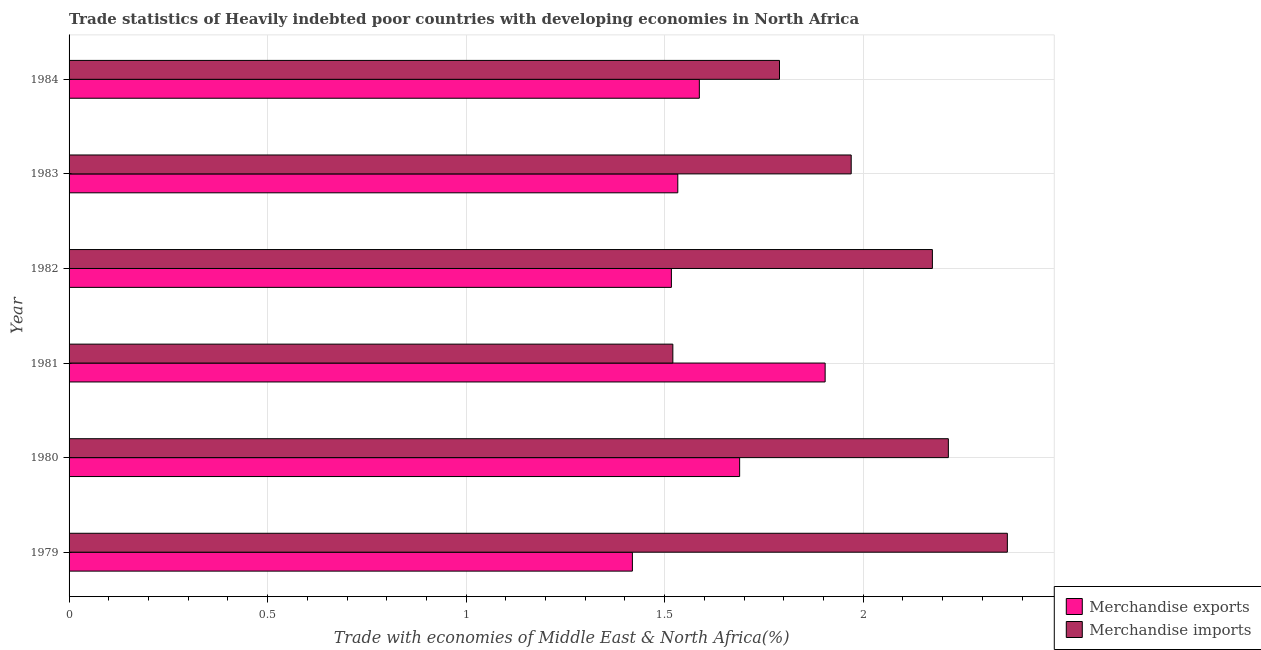Are the number of bars per tick equal to the number of legend labels?
Keep it short and to the point. Yes. How many bars are there on the 6th tick from the top?
Keep it short and to the point. 2. What is the label of the 4th group of bars from the top?
Offer a terse response. 1981. What is the merchandise imports in 1984?
Offer a terse response. 1.79. Across all years, what is the maximum merchandise exports?
Your answer should be very brief. 1.9. Across all years, what is the minimum merchandise exports?
Your answer should be very brief. 1.42. In which year was the merchandise imports maximum?
Ensure brevity in your answer.  1979. In which year was the merchandise exports minimum?
Keep it short and to the point. 1979. What is the total merchandise imports in the graph?
Your answer should be compact. 12.03. What is the difference between the merchandise exports in 1983 and that in 1984?
Make the answer very short. -0.05. What is the difference between the merchandise exports in 1979 and the merchandise imports in 1984?
Your response must be concise. -0.37. What is the average merchandise exports per year?
Give a very brief answer. 1.61. In the year 1979, what is the difference between the merchandise exports and merchandise imports?
Your response must be concise. -0.94. In how many years, is the merchandise exports greater than 1 %?
Keep it short and to the point. 6. What is the ratio of the merchandise exports in 1979 to that in 1983?
Your answer should be compact. 0.93. Is the merchandise exports in 1981 less than that in 1982?
Ensure brevity in your answer.  No. What is the difference between the highest and the second highest merchandise imports?
Your response must be concise. 0.15. What is the difference between the highest and the lowest merchandise exports?
Your answer should be very brief. 0.49. In how many years, is the merchandise imports greater than the average merchandise imports taken over all years?
Offer a very short reply. 3. What does the 2nd bar from the bottom in 1979 represents?
Offer a very short reply. Merchandise imports. Are all the bars in the graph horizontal?
Provide a succinct answer. Yes. What is the difference between two consecutive major ticks on the X-axis?
Offer a terse response. 0.5. Are the values on the major ticks of X-axis written in scientific E-notation?
Your answer should be compact. No. Does the graph contain any zero values?
Make the answer very short. No. Does the graph contain grids?
Your answer should be compact. Yes. How are the legend labels stacked?
Give a very brief answer. Vertical. What is the title of the graph?
Provide a succinct answer. Trade statistics of Heavily indebted poor countries with developing economies in North Africa. What is the label or title of the X-axis?
Ensure brevity in your answer.  Trade with economies of Middle East & North Africa(%). What is the Trade with economies of Middle East & North Africa(%) of Merchandise exports in 1979?
Ensure brevity in your answer.  1.42. What is the Trade with economies of Middle East & North Africa(%) in Merchandise imports in 1979?
Make the answer very short. 2.36. What is the Trade with economies of Middle East & North Africa(%) in Merchandise exports in 1980?
Provide a short and direct response. 1.69. What is the Trade with economies of Middle East & North Africa(%) in Merchandise imports in 1980?
Offer a very short reply. 2.21. What is the Trade with economies of Middle East & North Africa(%) in Merchandise exports in 1981?
Provide a succinct answer. 1.9. What is the Trade with economies of Middle East & North Africa(%) in Merchandise imports in 1981?
Ensure brevity in your answer.  1.52. What is the Trade with economies of Middle East & North Africa(%) of Merchandise exports in 1982?
Ensure brevity in your answer.  1.52. What is the Trade with economies of Middle East & North Africa(%) of Merchandise imports in 1982?
Offer a terse response. 2.17. What is the Trade with economies of Middle East & North Africa(%) in Merchandise exports in 1983?
Your response must be concise. 1.53. What is the Trade with economies of Middle East & North Africa(%) in Merchandise imports in 1983?
Provide a succinct answer. 1.97. What is the Trade with economies of Middle East & North Africa(%) of Merchandise exports in 1984?
Provide a short and direct response. 1.59. What is the Trade with economies of Middle East & North Africa(%) of Merchandise imports in 1984?
Offer a terse response. 1.79. Across all years, what is the maximum Trade with economies of Middle East & North Africa(%) in Merchandise exports?
Provide a succinct answer. 1.9. Across all years, what is the maximum Trade with economies of Middle East & North Africa(%) in Merchandise imports?
Your response must be concise. 2.36. Across all years, what is the minimum Trade with economies of Middle East & North Africa(%) of Merchandise exports?
Ensure brevity in your answer.  1.42. Across all years, what is the minimum Trade with economies of Middle East & North Africa(%) in Merchandise imports?
Give a very brief answer. 1.52. What is the total Trade with economies of Middle East & North Africa(%) of Merchandise exports in the graph?
Provide a succinct answer. 9.65. What is the total Trade with economies of Middle East & North Africa(%) in Merchandise imports in the graph?
Your answer should be very brief. 12.03. What is the difference between the Trade with economies of Middle East & North Africa(%) of Merchandise exports in 1979 and that in 1980?
Give a very brief answer. -0.27. What is the difference between the Trade with economies of Middle East & North Africa(%) of Merchandise imports in 1979 and that in 1980?
Keep it short and to the point. 0.15. What is the difference between the Trade with economies of Middle East & North Africa(%) of Merchandise exports in 1979 and that in 1981?
Your answer should be compact. -0.49. What is the difference between the Trade with economies of Middle East & North Africa(%) in Merchandise imports in 1979 and that in 1981?
Your answer should be very brief. 0.84. What is the difference between the Trade with economies of Middle East & North Africa(%) of Merchandise exports in 1979 and that in 1982?
Offer a terse response. -0.1. What is the difference between the Trade with economies of Middle East & North Africa(%) in Merchandise imports in 1979 and that in 1982?
Your response must be concise. 0.19. What is the difference between the Trade with economies of Middle East & North Africa(%) in Merchandise exports in 1979 and that in 1983?
Make the answer very short. -0.11. What is the difference between the Trade with economies of Middle East & North Africa(%) of Merchandise imports in 1979 and that in 1983?
Ensure brevity in your answer.  0.39. What is the difference between the Trade with economies of Middle East & North Africa(%) in Merchandise exports in 1979 and that in 1984?
Offer a very short reply. -0.17. What is the difference between the Trade with economies of Middle East & North Africa(%) of Merchandise imports in 1979 and that in 1984?
Your answer should be very brief. 0.57. What is the difference between the Trade with economies of Middle East & North Africa(%) of Merchandise exports in 1980 and that in 1981?
Offer a terse response. -0.22. What is the difference between the Trade with economies of Middle East & North Africa(%) of Merchandise imports in 1980 and that in 1981?
Make the answer very short. 0.69. What is the difference between the Trade with economies of Middle East & North Africa(%) in Merchandise exports in 1980 and that in 1982?
Ensure brevity in your answer.  0.17. What is the difference between the Trade with economies of Middle East & North Africa(%) of Merchandise imports in 1980 and that in 1982?
Give a very brief answer. 0.04. What is the difference between the Trade with economies of Middle East & North Africa(%) in Merchandise exports in 1980 and that in 1983?
Offer a very short reply. 0.16. What is the difference between the Trade with economies of Middle East & North Africa(%) in Merchandise imports in 1980 and that in 1983?
Keep it short and to the point. 0.24. What is the difference between the Trade with economies of Middle East & North Africa(%) of Merchandise exports in 1980 and that in 1984?
Offer a terse response. 0.1. What is the difference between the Trade with economies of Middle East & North Africa(%) of Merchandise imports in 1980 and that in 1984?
Your answer should be very brief. 0.43. What is the difference between the Trade with economies of Middle East & North Africa(%) of Merchandise exports in 1981 and that in 1982?
Provide a succinct answer. 0.39. What is the difference between the Trade with economies of Middle East & North Africa(%) of Merchandise imports in 1981 and that in 1982?
Your answer should be compact. -0.65. What is the difference between the Trade with economies of Middle East & North Africa(%) in Merchandise exports in 1981 and that in 1983?
Give a very brief answer. 0.37. What is the difference between the Trade with economies of Middle East & North Africa(%) of Merchandise imports in 1981 and that in 1983?
Give a very brief answer. -0.45. What is the difference between the Trade with economies of Middle East & North Africa(%) in Merchandise exports in 1981 and that in 1984?
Make the answer very short. 0.32. What is the difference between the Trade with economies of Middle East & North Africa(%) of Merchandise imports in 1981 and that in 1984?
Provide a succinct answer. -0.27. What is the difference between the Trade with economies of Middle East & North Africa(%) in Merchandise exports in 1982 and that in 1983?
Offer a very short reply. -0.02. What is the difference between the Trade with economies of Middle East & North Africa(%) of Merchandise imports in 1982 and that in 1983?
Make the answer very short. 0.2. What is the difference between the Trade with economies of Middle East & North Africa(%) in Merchandise exports in 1982 and that in 1984?
Offer a very short reply. -0.07. What is the difference between the Trade with economies of Middle East & North Africa(%) of Merchandise imports in 1982 and that in 1984?
Give a very brief answer. 0.39. What is the difference between the Trade with economies of Middle East & North Africa(%) in Merchandise exports in 1983 and that in 1984?
Provide a short and direct response. -0.05. What is the difference between the Trade with economies of Middle East & North Africa(%) in Merchandise imports in 1983 and that in 1984?
Offer a very short reply. 0.18. What is the difference between the Trade with economies of Middle East & North Africa(%) in Merchandise exports in 1979 and the Trade with economies of Middle East & North Africa(%) in Merchandise imports in 1980?
Offer a very short reply. -0.8. What is the difference between the Trade with economies of Middle East & North Africa(%) in Merchandise exports in 1979 and the Trade with economies of Middle East & North Africa(%) in Merchandise imports in 1981?
Give a very brief answer. -0.1. What is the difference between the Trade with economies of Middle East & North Africa(%) of Merchandise exports in 1979 and the Trade with economies of Middle East & North Africa(%) of Merchandise imports in 1982?
Provide a short and direct response. -0.76. What is the difference between the Trade with economies of Middle East & North Africa(%) of Merchandise exports in 1979 and the Trade with economies of Middle East & North Africa(%) of Merchandise imports in 1983?
Give a very brief answer. -0.55. What is the difference between the Trade with economies of Middle East & North Africa(%) of Merchandise exports in 1979 and the Trade with economies of Middle East & North Africa(%) of Merchandise imports in 1984?
Give a very brief answer. -0.37. What is the difference between the Trade with economies of Middle East & North Africa(%) in Merchandise exports in 1980 and the Trade with economies of Middle East & North Africa(%) in Merchandise imports in 1981?
Make the answer very short. 0.17. What is the difference between the Trade with economies of Middle East & North Africa(%) of Merchandise exports in 1980 and the Trade with economies of Middle East & North Africa(%) of Merchandise imports in 1982?
Keep it short and to the point. -0.49. What is the difference between the Trade with economies of Middle East & North Africa(%) in Merchandise exports in 1980 and the Trade with economies of Middle East & North Africa(%) in Merchandise imports in 1983?
Your answer should be compact. -0.28. What is the difference between the Trade with economies of Middle East & North Africa(%) of Merchandise exports in 1980 and the Trade with economies of Middle East & North Africa(%) of Merchandise imports in 1984?
Provide a succinct answer. -0.1. What is the difference between the Trade with economies of Middle East & North Africa(%) of Merchandise exports in 1981 and the Trade with economies of Middle East & North Africa(%) of Merchandise imports in 1982?
Ensure brevity in your answer.  -0.27. What is the difference between the Trade with economies of Middle East & North Africa(%) of Merchandise exports in 1981 and the Trade with economies of Middle East & North Africa(%) of Merchandise imports in 1983?
Provide a succinct answer. -0.07. What is the difference between the Trade with economies of Middle East & North Africa(%) in Merchandise exports in 1981 and the Trade with economies of Middle East & North Africa(%) in Merchandise imports in 1984?
Give a very brief answer. 0.12. What is the difference between the Trade with economies of Middle East & North Africa(%) of Merchandise exports in 1982 and the Trade with economies of Middle East & North Africa(%) of Merchandise imports in 1983?
Offer a terse response. -0.45. What is the difference between the Trade with economies of Middle East & North Africa(%) in Merchandise exports in 1982 and the Trade with economies of Middle East & North Africa(%) in Merchandise imports in 1984?
Give a very brief answer. -0.27. What is the difference between the Trade with economies of Middle East & North Africa(%) of Merchandise exports in 1983 and the Trade with economies of Middle East & North Africa(%) of Merchandise imports in 1984?
Ensure brevity in your answer.  -0.26. What is the average Trade with economies of Middle East & North Africa(%) of Merchandise exports per year?
Ensure brevity in your answer.  1.61. What is the average Trade with economies of Middle East & North Africa(%) of Merchandise imports per year?
Ensure brevity in your answer.  2.01. In the year 1979, what is the difference between the Trade with economies of Middle East & North Africa(%) in Merchandise exports and Trade with economies of Middle East & North Africa(%) in Merchandise imports?
Keep it short and to the point. -0.94. In the year 1980, what is the difference between the Trade with economies of Middle East & North Africa(%) in Merchandise exports and Trade with economies of Middle East & North Africa(%) in Merchandise imports?
Offer a very short reply. -0.53. In the year 1981, what is the difference between the Trade with economies of Middle East & North Africa(%) in Merchandise exports and Trade with economies of Middle East & North Africa(%) in Merchandise imports?
Provide a short and direct response. 0.38. In the year 1982, what is the difference between the Trade with economies of Middle East & North Africa(%) of Merchandise exports and Trade with economies of Middle East & North Africa(%) of Merchandise imports?
Make the answer very short. -0.66. In the year 1983, what is the difference between the Trade with economies of Middle East & North Africa(%) in Merchandise exports and Trade with economies of Middle East & North Africa(%) in Merchandise imports?
Ensure brevity in your answer.  -0.44. In the year 1984, what is the difference between the Trade with economies of Middle East & North Africa(%) in Merchandise exports and Trade with economies of Middle East & North Africa(%) in Merchandise imports?
Make the answer very short. -0.2. What is the ratio of the Trade with economies of Middle East & North Africa(%) of Merchandise exports in 1979 to that in 1980?
Keep it short and to the point. 0.84. What is the ratio of the Trade with economies of Middle East & North Africa(%) in Merchandise imports in 1979 to that in 1980?
Provide a succinct answer. 1.07. What is the ratio of the Trade with economies of Middle East & North Africa(%) in Merchandise exports in 1979 to that in 1981?
Provide a succinct answer. 0.75. What is the ratio of the Trade with economies of Middle East & North Africa(%) of Merchandise imports in 1979 to that in 1981?
Offer a terse response. 1.55. What is the ratio of the Trade with economies of Middle East & North Africa(%) of Merchandise exports in 1979 to that in 1982?
Offer a very short reply. 0.94. What is the ratio of the Trade with economies of Middle East & North Africa(%) in Merchandise imports in 1979 to that in 1982?
Provide a short and direct response. 1.09. What is the ratio of the Trade with economies of Middle East & North Africa(%) of Merchandise exports in 1979 to that in 1983?
Your answer should be very brief. 0.93. What is the ratio of the Trade with economies of Middle East & North Africa(%) in Merchandise imports in 1979 to that in 1983?
Keep it short and to the point. 1.2. What is the ratio of the Trade with economies of Middle East & North Africa(%) of Merchandise exports in 1979 to that in 1984?
Provide a short and direct response. 0.89. What is the ratio of the Trade with economies of Middle East & North Africa(%) of Merchandise imports in 1979 to that in 1984?
Offer a very short reply. 1.32. What is the ratio of the Trade with economies of Middle East & North Africa(%) of Merchandise exports in 1980 to that in 1981?
Keep it short and to the point. 0.89. What is the ratio of the Trade with economies of Middle East & North Africa(%) of Merchandise imports in 1980 to that in 1981?
Your response must be concise. 1.46. What is the ratio of the Trade with economies of Middle East & North Africa(%) in Merchandise exports in 1980 to that in 1982?
Your answer should be compact. 1.11. What is the ratio of the Trade with economies of Middle East & North Africa(%) in Merchandise imports in 1980 to that in 1982?
Give a very brief answer. 1.02. What is the ratio of the Trade with economies of Middle East & North Africa(%) in Merchandise exports in 1980 to that in 1983?
Your answer should be very brief. 1.1. What is the ratio of the Trade with economies of Middle East & North Africa(%) of Merchandise imports in 1980 to that in 1983?
Your answer should be compact. 1.12. What is the ratio of the Trade with economies of Middle East & North Africa(%) of Merchandise exports in 1980 to that in 1984?
Ensure brevity in your answer.  1.06. What is the ratio of the Trade with economies of Middle East & North Africa(%) of Merchandise imports in 1980 to that in 1984?
Ensure brevity in your answer.  1.24. What is the ratio of the Trade with economies of Middle East & North Africa(%) of Merchandise exports in 1981 to that in 1982?
Your answer should be very brief. 1.26. What is the ratio of the Trade with economies of Middle East & North Africa(%) in Merchandise imports in 1981 to that in 1982?
Make the answer very short. 0.7. What is the ratio of the Trade with economies of Middle East & North Africa(%) in Merchandise exports in 1981 to that in 1983?
Make the answer very short. 1.24. What is the ratio of the Trade with economies of Middle East & North Africa(%) in Merchandise imports in 1981 to that in 1983?
Your response must be concise. 0.77. What is the ratio of the Trade with economies of Middle East & North Africa(%) of Merchandise exports in 1981 to that in 1984?
Make the answer very short. 1.2. What is the ratio of the Trade with economies of Middle East & North Africa(%) in Merchandise imports in 1981 to that in 1984?
Offer a terse response. 0.85. What is the ratio of the Trade with economies of Middle East & North Africa(%) of Merchandise exports in 1982 to that in 1983?
Offer a very short reply. 0.99. What is the ratio of the Trade with economies of Middle East & North Africa(%) of Merchandise imports in 1982 to that in 1983?
Provide a succinct answer. 1.1. What is the ratio of the Trade with economies of Middle East & North Africa(%) of Merchandise exports in 1982 to that in 1984?
Give a very brief answer. 0.96. What is the ratio of the Trade with economies of Middle East & North Africa(%) in Merchandise imports in 1982 to that in 1984?
Offer a very short reply. 1.22. What is the ratio of the Trade with economies of Middle East & North Africa(%) of Merchandise exports in 1983 to that in 1984?
Your answer should be compact. 0.97. What is the ratio of the Trade with economies of Middle East & North Africa(%) in Merchandise imports in 1983 to that in 1984?
Offer a terse response. 1.1. What is the difference between the highest and the second highest Trade with economies of Middle East & North Africa(%) in Merchandise exports?
Offer a very short reply. 0.22. What is the difference between the highest and the second highest Trade with economies of Middle East & North Africa(%) of Merchandise imports?
Your answer should be compact. 0.15. What is the difference between the highest and the lowest Trade with economies of Middle East & North Africa(%) of Merchandise exports?
Offer a very short reply. 0.49. What is the difference between the highest and the lowest Trade with economies of Middle East & North Africa(%) in Merchandise imports?
Keep it short and to the point. 0.84. 